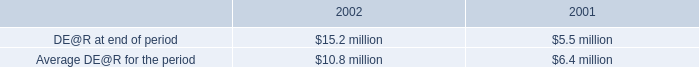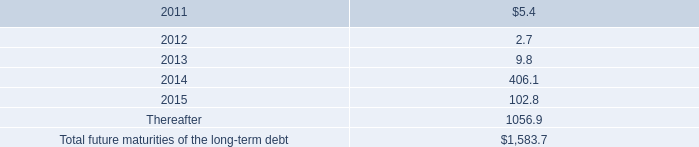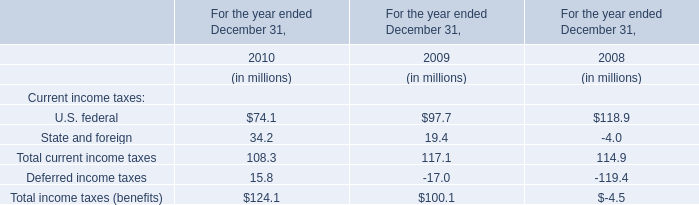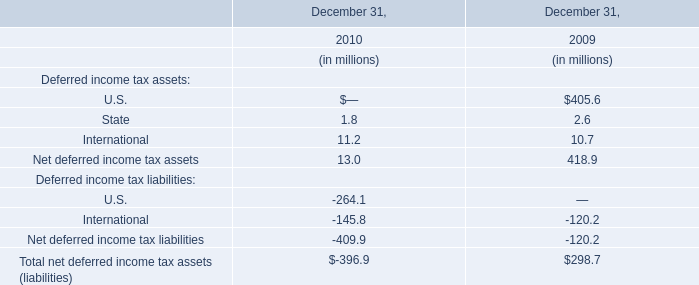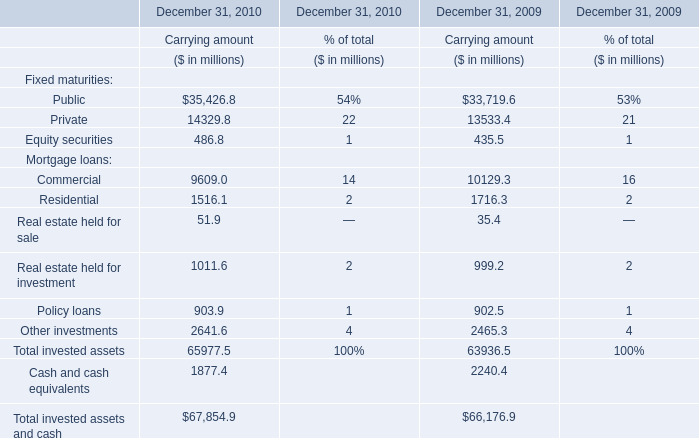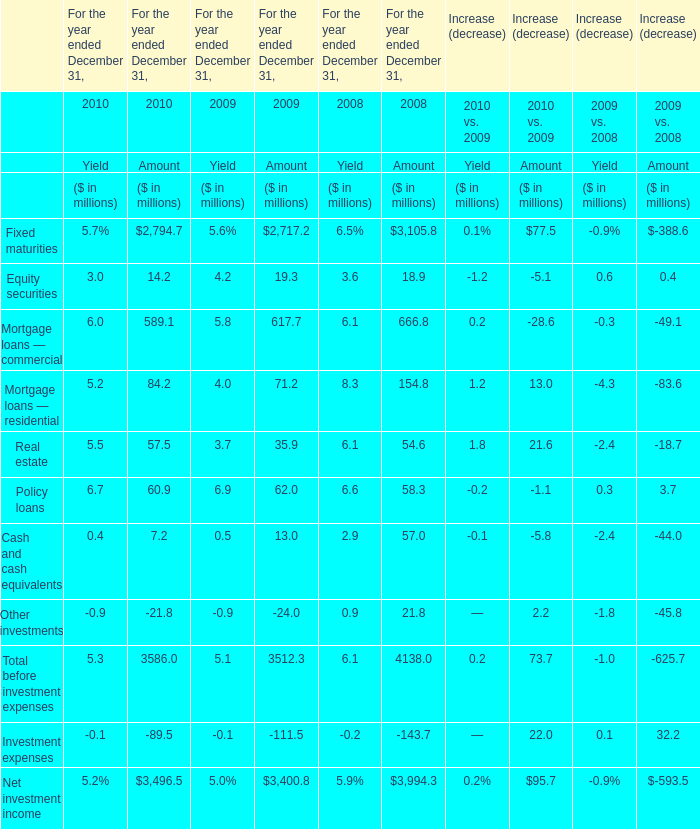For the year ended December 31,which year is the amount of Cash and cash equivalents greater than 50 million? 
Answer: 2008. 